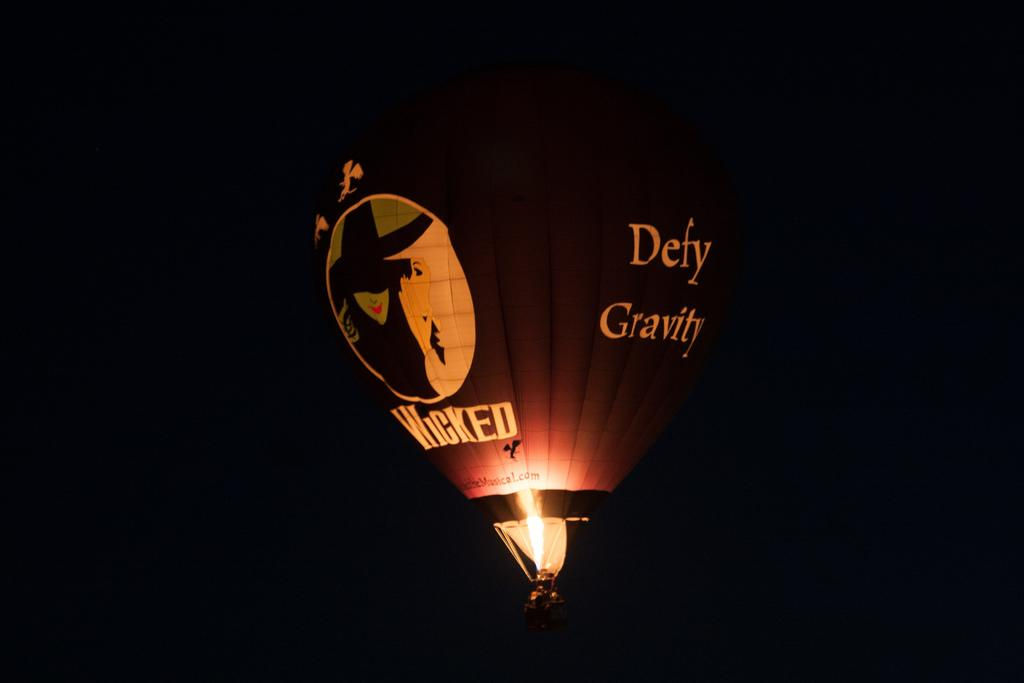What is the main subject of the image? There is a hot air balloon in the image. What type of mouth is visible on the hot air balloon in the image? There is no mouth present on the hot air balloon in the image, as it is an inanimate object and does not have a mouth. 